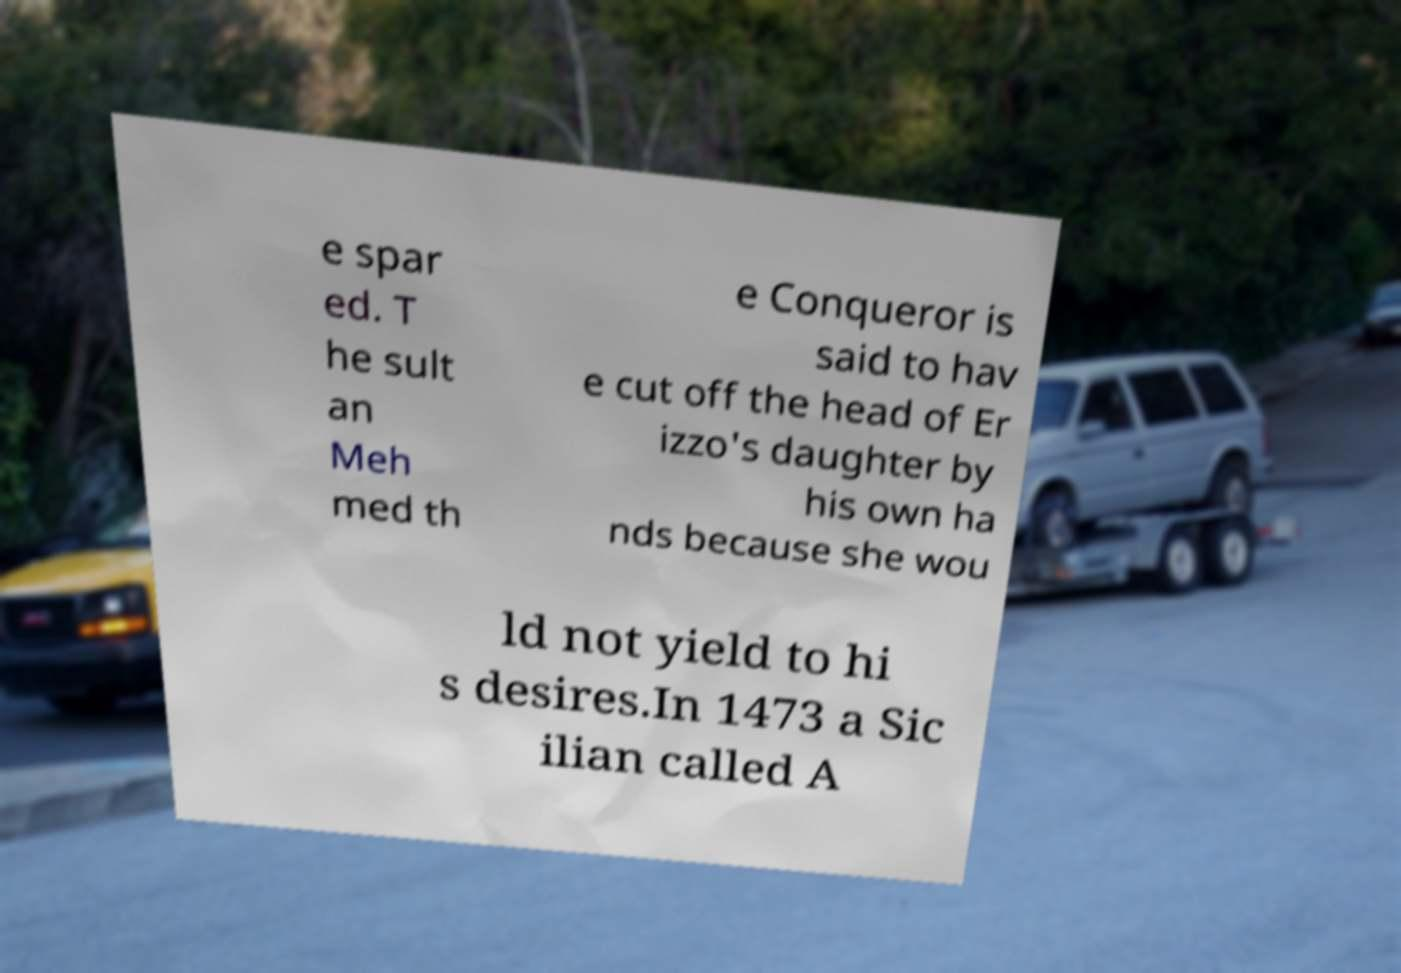There's text embedded in this image that I need extracted. Can you transcribe it verbatim? e spar ed. T he sult an Meh med th e Conqueror is said to hav e cut off the head of Er izzo's daughter by his own ha nds because she wou ld not yield to hi s desires.In 1473 a Sic ilian called A 